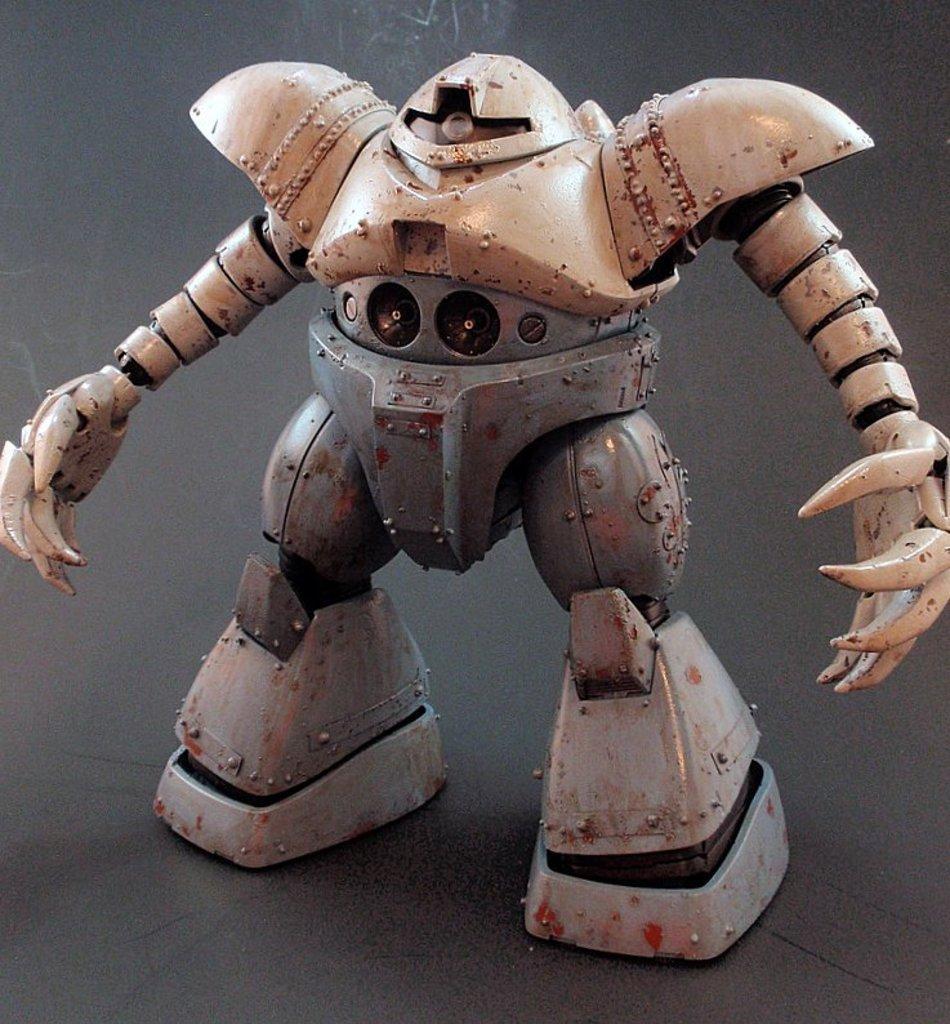Describe this image in one or two sentences. Here in this picture we can see a robot toy present on the floor over there. 